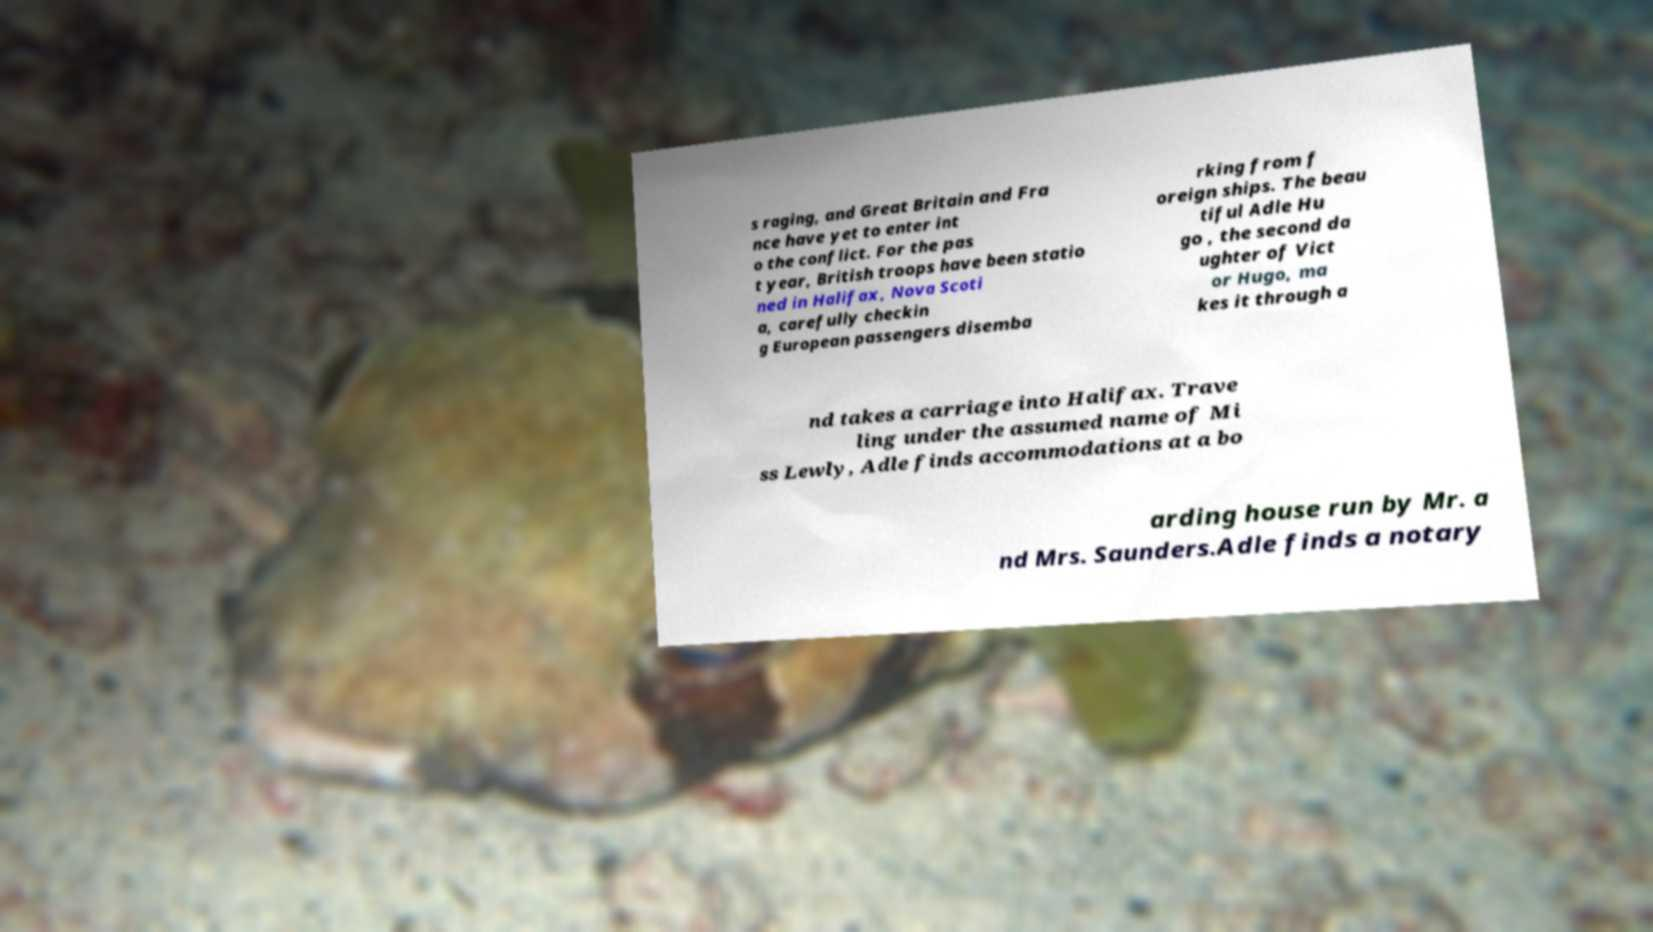Could you assist in decoding the text presented in this image and type it out clearly? s raging, and Great Britain and Fra nce have yet to enter int o the conflict. For the pas t year, British troops have been statio ned in Halifax, Nova Scoti a, carefully checkin g European passengers disemba rking from f oreign ships. The beau tiful Adle Hu go , the second da ughter of Vict or Hugo, ma kes it through a nd takes a carriage into Halifax. Trave ling under the assumed name of Mi ss Lewly, Adle finds accommodations at a bo arding house run by Mr. a nd Mrs. Saunders.Adle finds a notary 